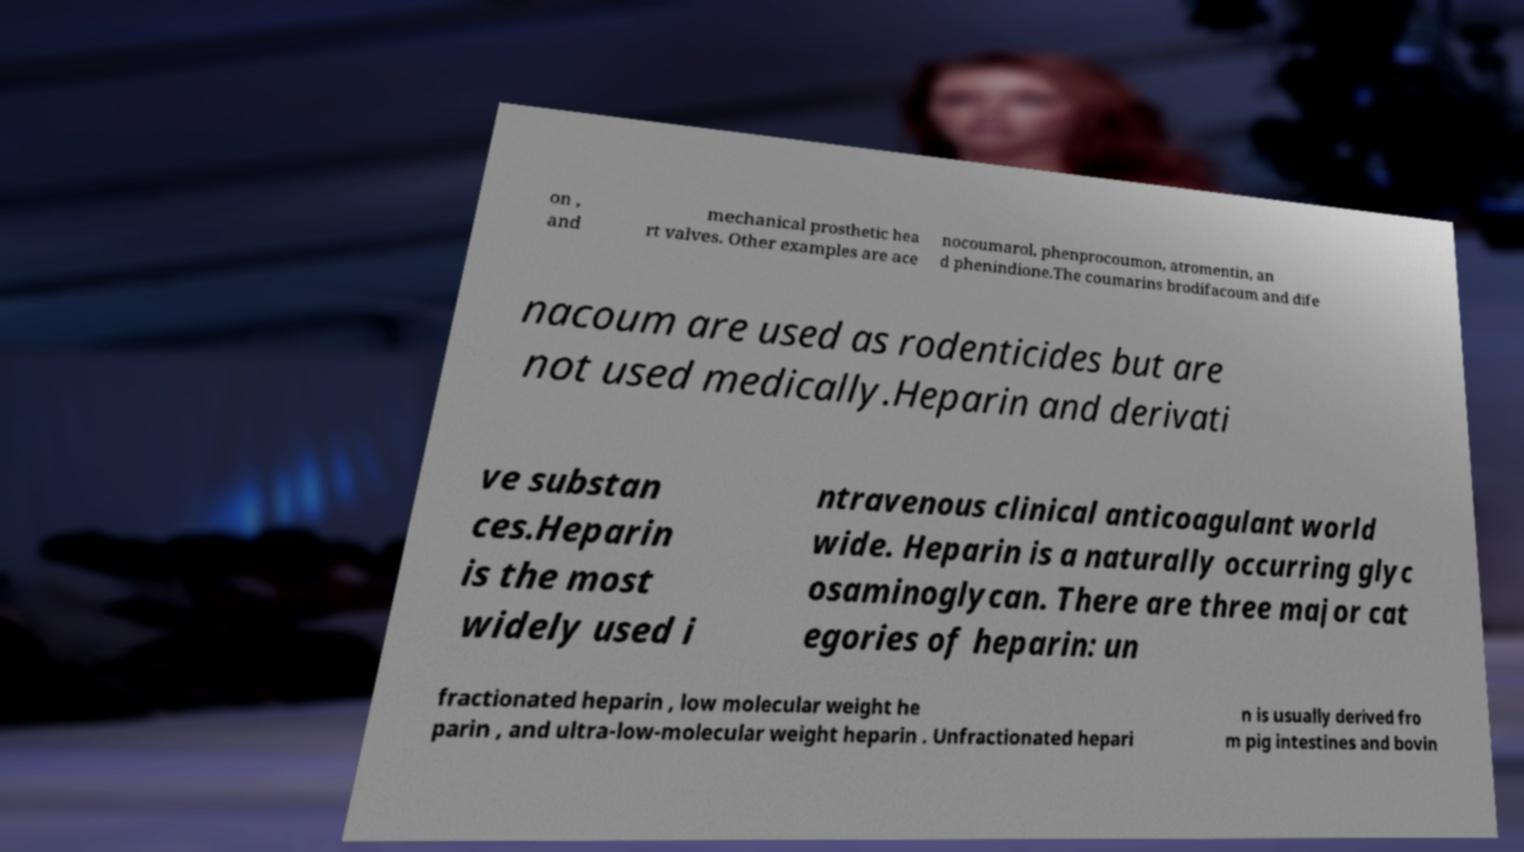I need the written content from this picture converted into text. Can you do that? on , and mechanical prosthetic hea rt valves. Other examples are ace nocoumarol, phenprocoumon, atromentin, an d phenindione.The coumarins brodifacoum and dife nacoum are used as rodenticides but are not used medically.Heparin and derivati ve substan ces.Heparin is the most widely used i ntravenous clinical anticoagulant world wide. Heparin is a naturally occurring glyc osaminoglycan. There are three major cat egories of heparin: un fractionated heparin , low molecular weight he parin , and ultra-low-molecular weight heparin . Unfractionated hepari n is usually derived fro m pig intestines and bovin 